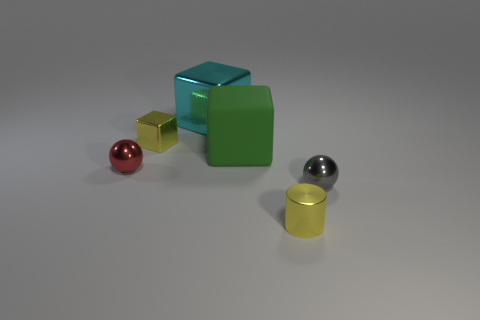Is there any other thing that has the same material as the large green cube?
Your answer should be very brief. No. There is a cube that is the same color as the shiny cylinder; what is its size?
Offer a terse response. Small. What number of rubber things are either big red spheres or gray objects?
Provide a short and direct response. 0. Are there any tiny yellow metallic things in front of the tiny yellow object behind the small yellow metallic thing that is to the right of the green block?
Ensure brevity in your answer.  Yes. There is a red sphere; how many tiny yellow things are in front of it?
Your answer should be compact. 1. What number of small things are either green blocks or metallic balls?
Offer a terse response. 2. What shape is the small red thing on the left side of the big green object?
Keep it short and to the point. Sphere. Are there any small things that have the same color as the cylinder?
Keep it short and to the point. Yes. Do the yellow cube on the left side of the tiny metallic cylinder and the yellow thing on the right side of the rubber object have the same size?
Offer a terse response. Yes. Is the number of yellow objects behind the cylinder greater than the number of large rubber cubes that are right of the green thing?
Give a very brief answer. Yes. 